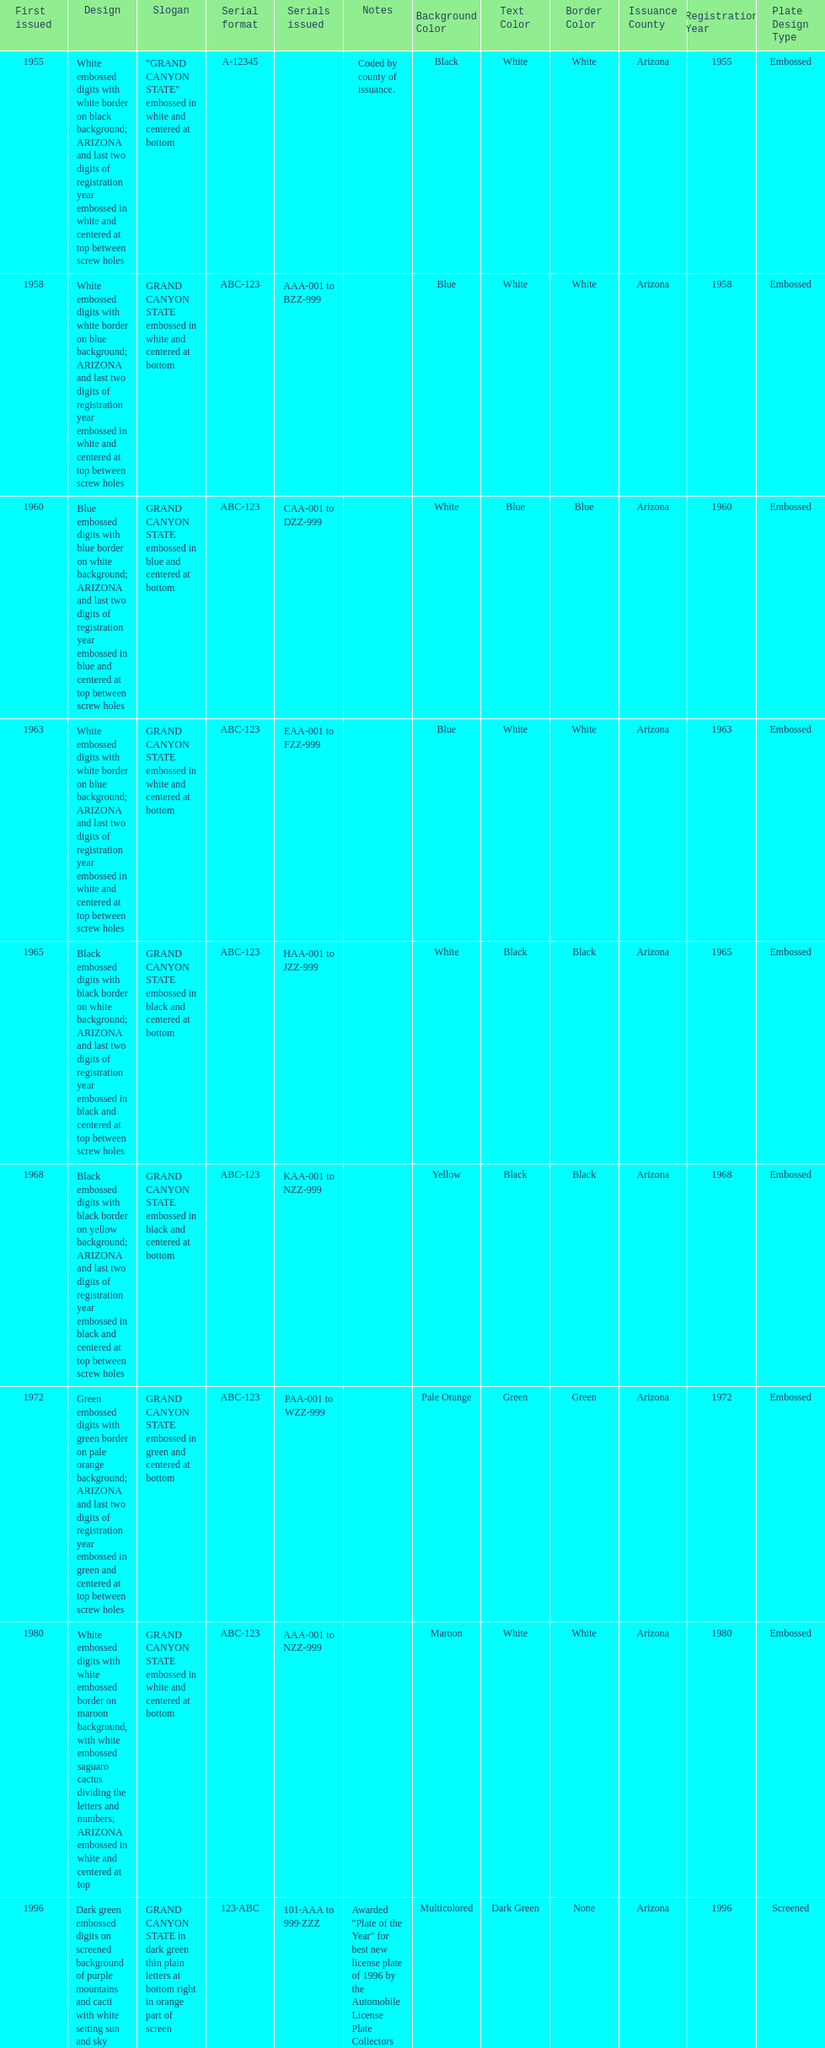Which year featured the license plate with the least characters? 1955. 